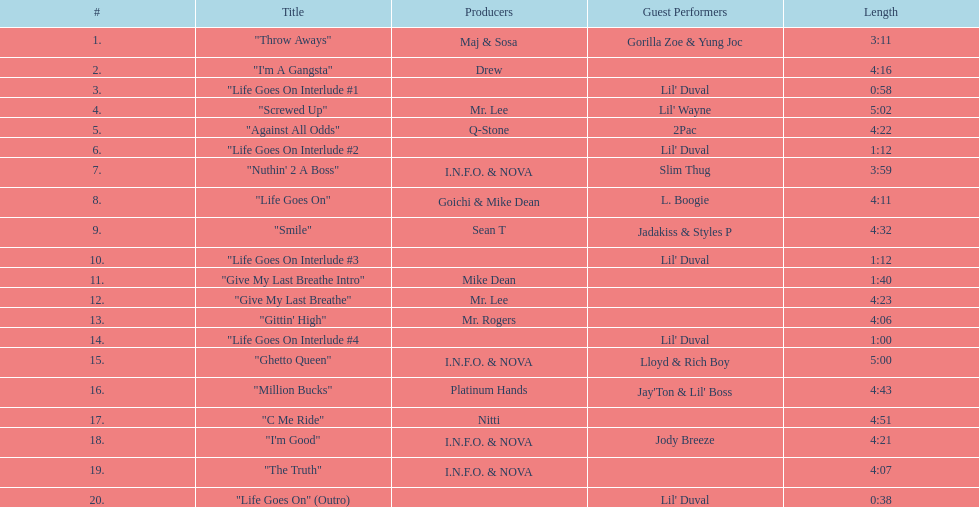What is the initial song featuring lil' duval? "Life Goes On Interlude #1. Can you parse all the data within this table? {'header': ['#', 'Title', 'Producers', 'Guest Performers', 'Length'], 'rows': [['1.', '"Throw Aways"', 'Maj & Sosa', 'Gorilla Zoe & Yung Joc', '3:11'], ['2.', '"I\'m A Gangsta"', 'Drew', '', '4:16'], ['3.', '"Life Goes On Interlude #1', '', "Lil' Duval", '0:58'], ['4.', '"Screwed Up"', 'Mr. Lee', "Lil' Wayne", '5:02'], ['5.', '"Against All Odds"', 'Q-Stone', '2Pac', '4:22'], ['6.', '"Life Goes On Interlude #2', '', "Lil' Duval", '1:12'], ['7.', '"Nuthin\' 2 A Boss"', 'I.N.F.O. & NOVA', 'Slim Thug', '3:59'], ['8.', '"Life Goes On"', 'Goichi & Mike Dean', 'L. Boogie', '4:11'], ['9.', '"Smile"', 'Sean T', 'Jadakiss & Styles P', '4:32'], ['10.', '"Life Goes On Interlude #3', '', "Lil' Duval", '1:12'], ['11.', '"Give My Last Breathe Intro"', 'Mike Dean', '', '1:40'], ['12.', '"Give My Last Breathe"', 'Mr. Lee', '', '4:23'], ['13.', '"Gittin\' High"', 'Mr. Rogers', '', '4:06'], ['14.', '"Life Goes On Interlude #4', '', "Lil' Duval", '1:00'], ['15.', '"Ghetto Queen"', 'I.N.F.O. & NOVA', 'Lloyd & Rich Boy', '5:00'], ['16.', '"Million Bucks"', 'Platinum Hands', "Jay'Ton & Lil' Boss", '4:43'], ['17.', '"C Me Ride"', 'Nitti', '', '4:51'], ['18.', '"I\'m Good"', 'I.N.F.O. & NOVA', 'Jody Breeze', '4:21'], ['19.', '"The Truth"', 'I.N.F.O. & NOVA', '', '4:07'], ['20.', '"Life Goes On" (Outro)', '', "Lil' Duval", '0:38']]} 